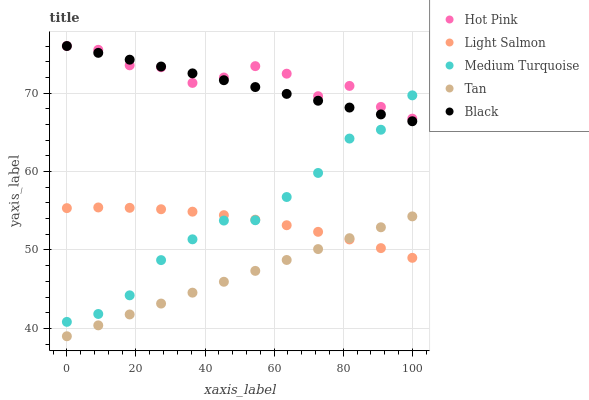Does Tan have the minimum area under the curve?
Answer yes or no. Yes. Does Hot Pink have the maximum area under the curve?
Answer yes or no. Yes. Does Black have the minimum area under the curve?
Answer yes or no. No. Does Black have the maximum area under the curve?
Answer yes or no. No. Is Tan the smoothest?
Answer yes or no. Yes. Is Hot Pink the roughest?
Answer yes or no. Yes. Is Black the smoothest?
Answer yes or no. No. Is Black the roughest?
Answer yes or no. No. Does Tan have the lowest value?
Answer yes or no. Yes. Does Black have the lowest value?
Answer yes or no. No. Does Black have the highest value?
Answer yes or no. Yes. Does Tan have the highest value?
Answer yes or no. No. Is Tan less than Medium Turquoise?
Answer yes or no. Yes. Is Black greater than Light Salmon?
Answer yes or no. Yes. Does Hot Pink intersect Medium Turquoise?
Answer yes or no. Yes. Is Hot Pink less than Medium Turquoise?
Answer yes or no. No. Is Hot Pink greater than Medium Turquoise?
Answer yes or no. No. Does Tan intersect Medium Turquoise?
Answer yes or no. No. 